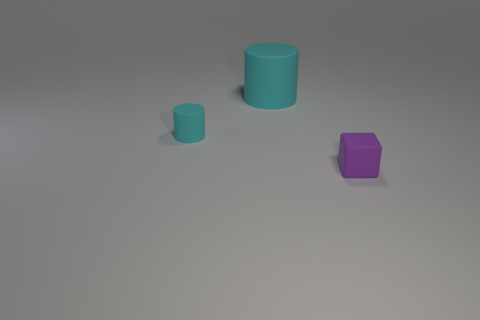What number of rubber things are tiny cylinders or small purple things?
Provide a short and direct response. 2. What is the size of the cyan cylinder behind the tiny cyan cylinder?
Your answer should be compact. Large. There is a cyan cylinder that is made of the same material as the large thing; what size is it?
Your answer should be very brief. Small. How many large rubber things have the same color as the cube?
Provide a succinct answer. 0. Are there any big cyan cylinders?
Your answer should be very brief. Yes. There is a small purple thing; does it have the same shape as the small object behind the purple matte object?
Give a very brief answer. No. What is the color of the rubber cylinder to the right of the small object left of the thing to the right of the big cyan matte cylinder?
Your response must be concise. Cyan. Are there any tiny cylinders to the left of the big cyan thing?
Your answer should be compact. Yes. What size is the other cylinder that is the same color as the big cylinder?
Make the answer very short. Small. Are there any other cubes that have the same material as the purple block?
Keep it short and to the point. No. 